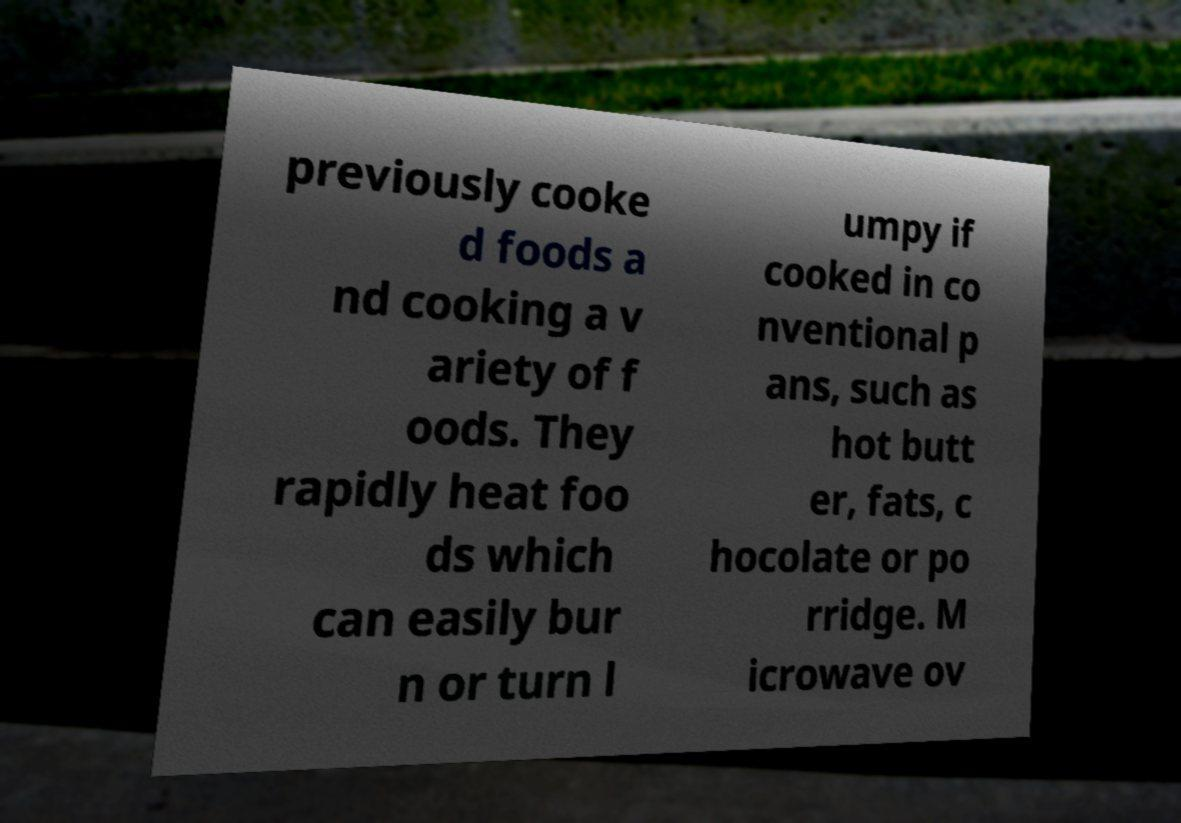Please identify and transcribe the text found in this image. previously cooke d foods a nd cooking a v ariety of f oods. They rapidly heat foo ds which can easily bur n or turn l umpy if cooked in co nventional p ans, such as hot butt er, fats, c hocolate or po rridge. M icrowave ov 